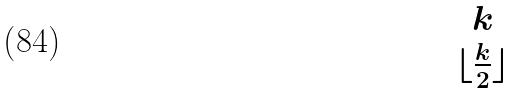<formula> <loc_0><loc_0><loc_500><loc_500>\begin{matrix} k \\ \lfloor \frac { k } { 2 } \rfloor \end{matrix}</formula> 